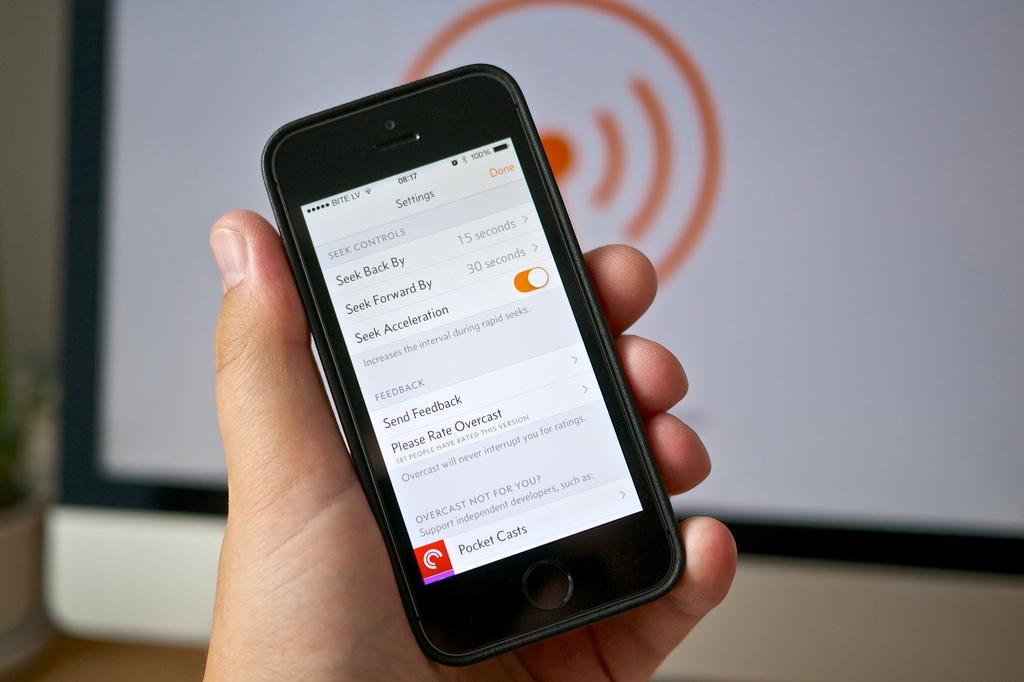How long is seek back by set to?
Your answer should be very brief. 15 seconds. How long is seek forward by set to?
Provide a short and direct response. 30 seconds. 